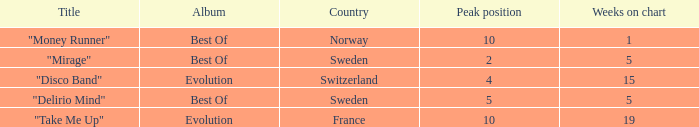What is the title of the single with the peak position of 10 and weeks on chart is less than 19? "Money Runner". 